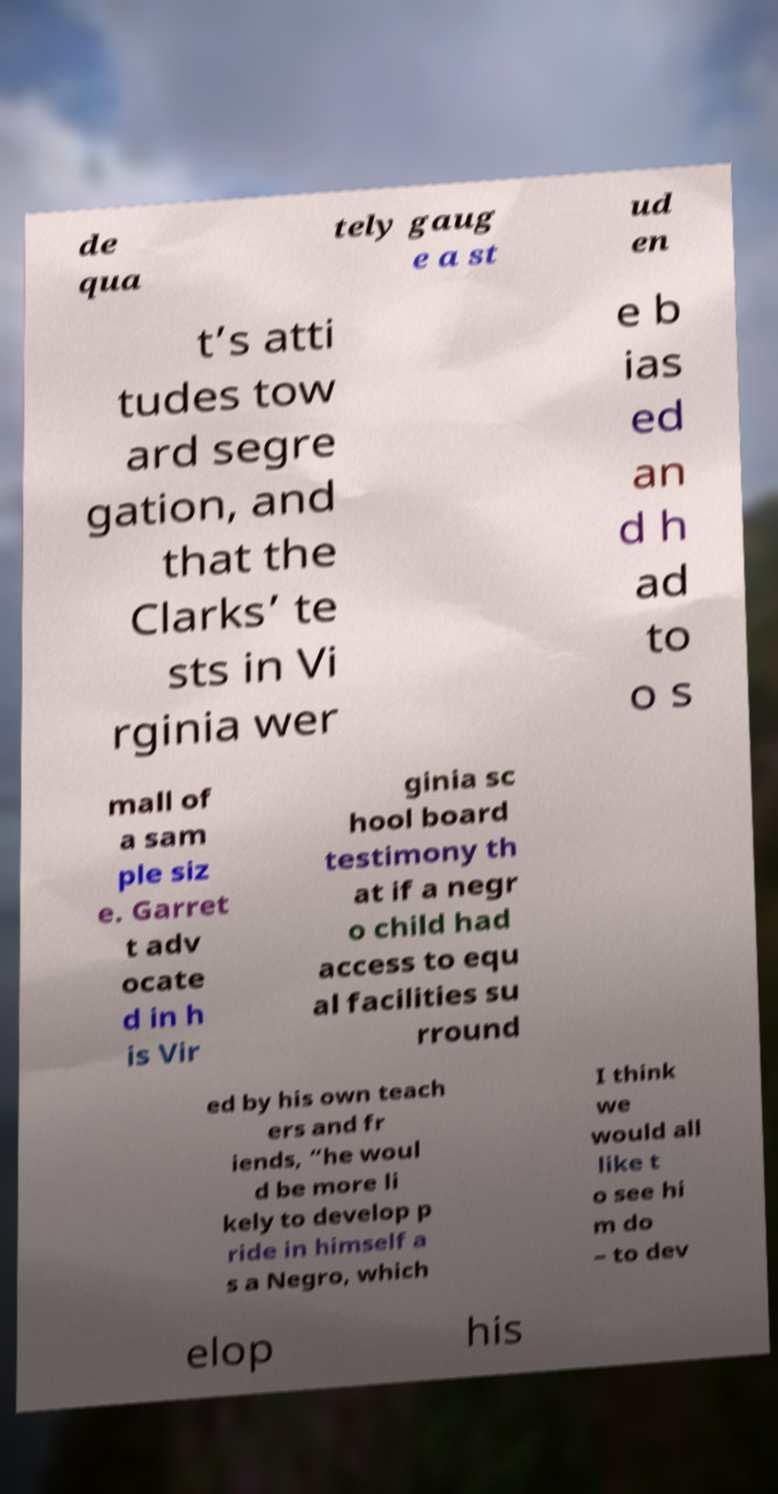Can you accurately transcribe the text from the provided image for me? de qua tely gaug e a st ud en t’s atti tudes tow ard segre gation, and that the Clarks’ te sts in Vi rginia wer e b ias ed an d h ad to o s mall of a sam ple siz e. Garret t adv ocate d in h is Vir ginia sc hool board testimony th at if a negr o child had access to equ al facilities su rround ed by his own teach ers and fr iends, “he woul d be more li kely to develop p ride in himself a s a Negro, which I think we would all like t o see hi m do – to dev elop his 